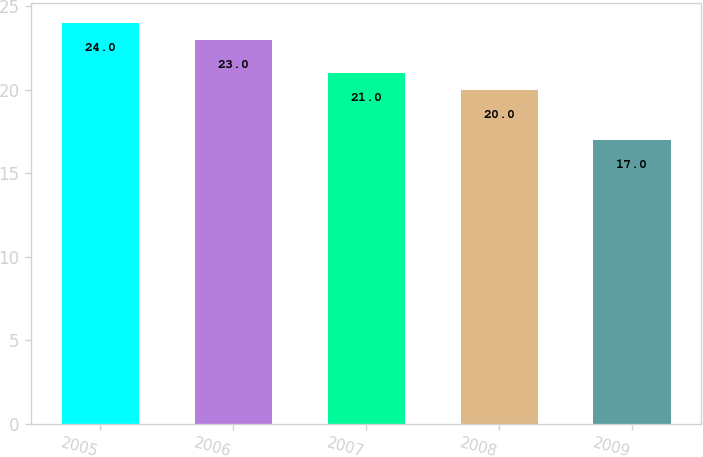Convert chart to OTSL. <chart><loc_0><loc_0><loc_500><loc_500><bar_chart><fcel>2005<fcel>2006<fcel>2007<fcel>2008<fcel>2009<nl><fcel>24<fcel>23<fcel>21<fcel>20<fcel>17<nl></chart> 